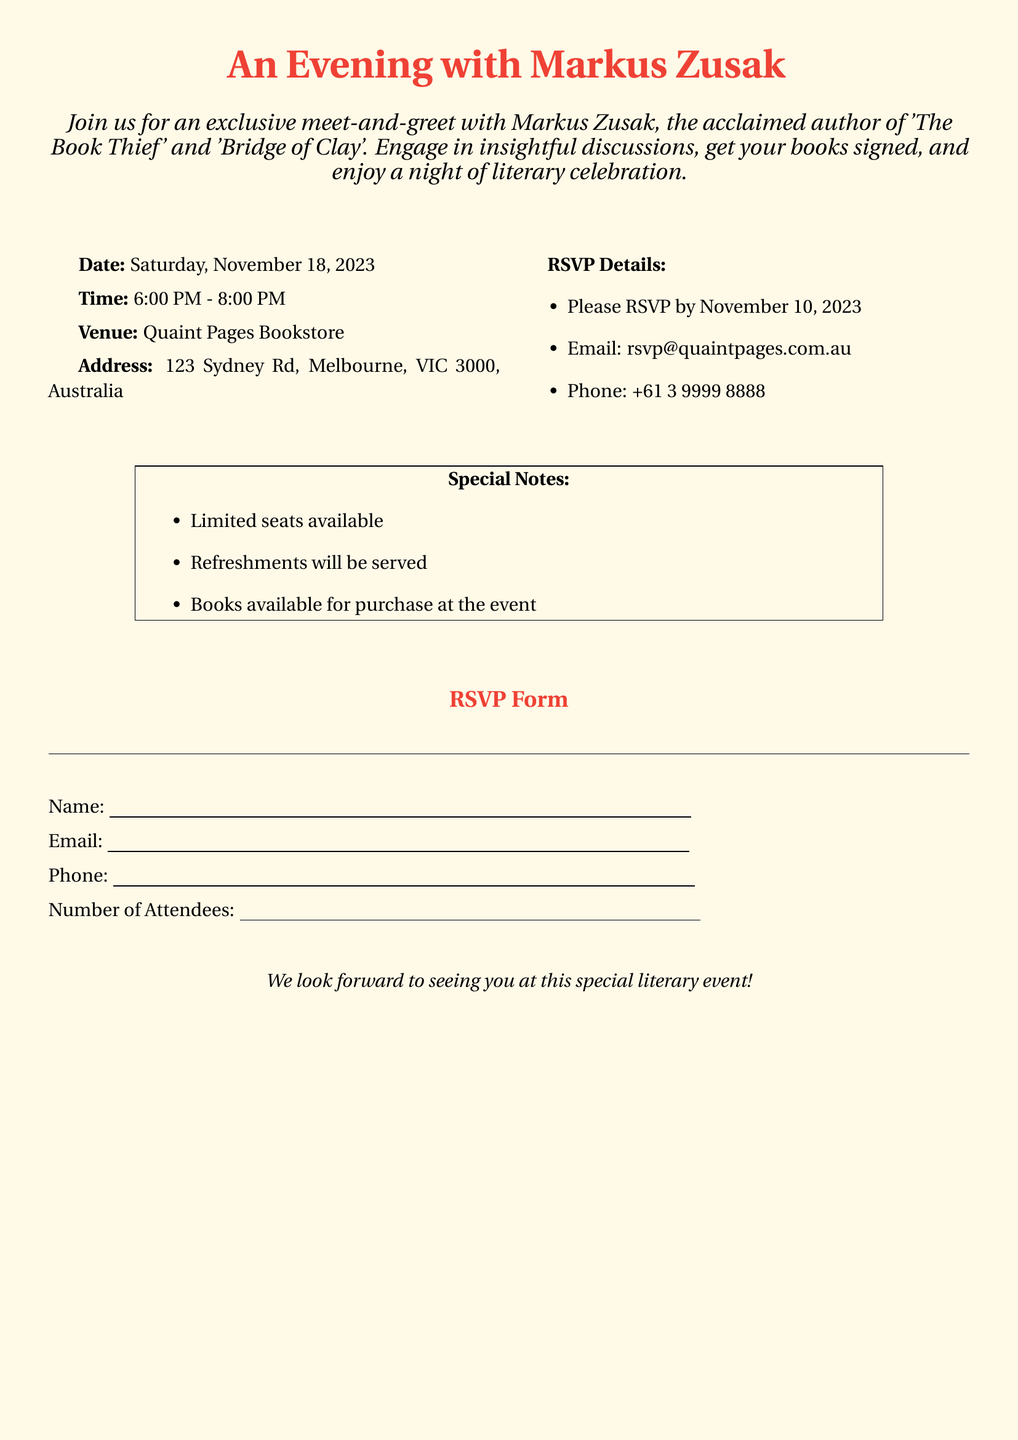What is the name of the author featured at the event? The author's name is mentioned prominently at the top of the document.
Answer: Markus Zusak What is the date of the event? The date is specified clearly in the event details section.
Answer: Saturday, November 18, 2023 What time does the meet-and-greet start? The starting time is provided in the time section of the document.
Answer: 6:00 PM Where is the venue located? The address of the venue is provided under the venue section.
Answer: 123 Sydney Rd, Melbourne, VIC 3000, Australia What is the RSVP deadline? The RSVP deadline is stated clearly in the RSVP details section.
Answer: November 10, 2023 How can attendees RSVP? The document specifies the methods of RSVP in the RSVP details section.
Answer: Email or Phone What will be served at the event? The document lists what will be available at the event under special notes.
Answer: Refreshments Is there a purchase opportunity at the event? The document indicates the availability of books for purchase in special notes.
Answer: Yes How many attendees can someone indicate on the RSVP form? The RSVP form allows for a specific number of attendees as specified in the RSVP section.
Answer: Number of Attendees 